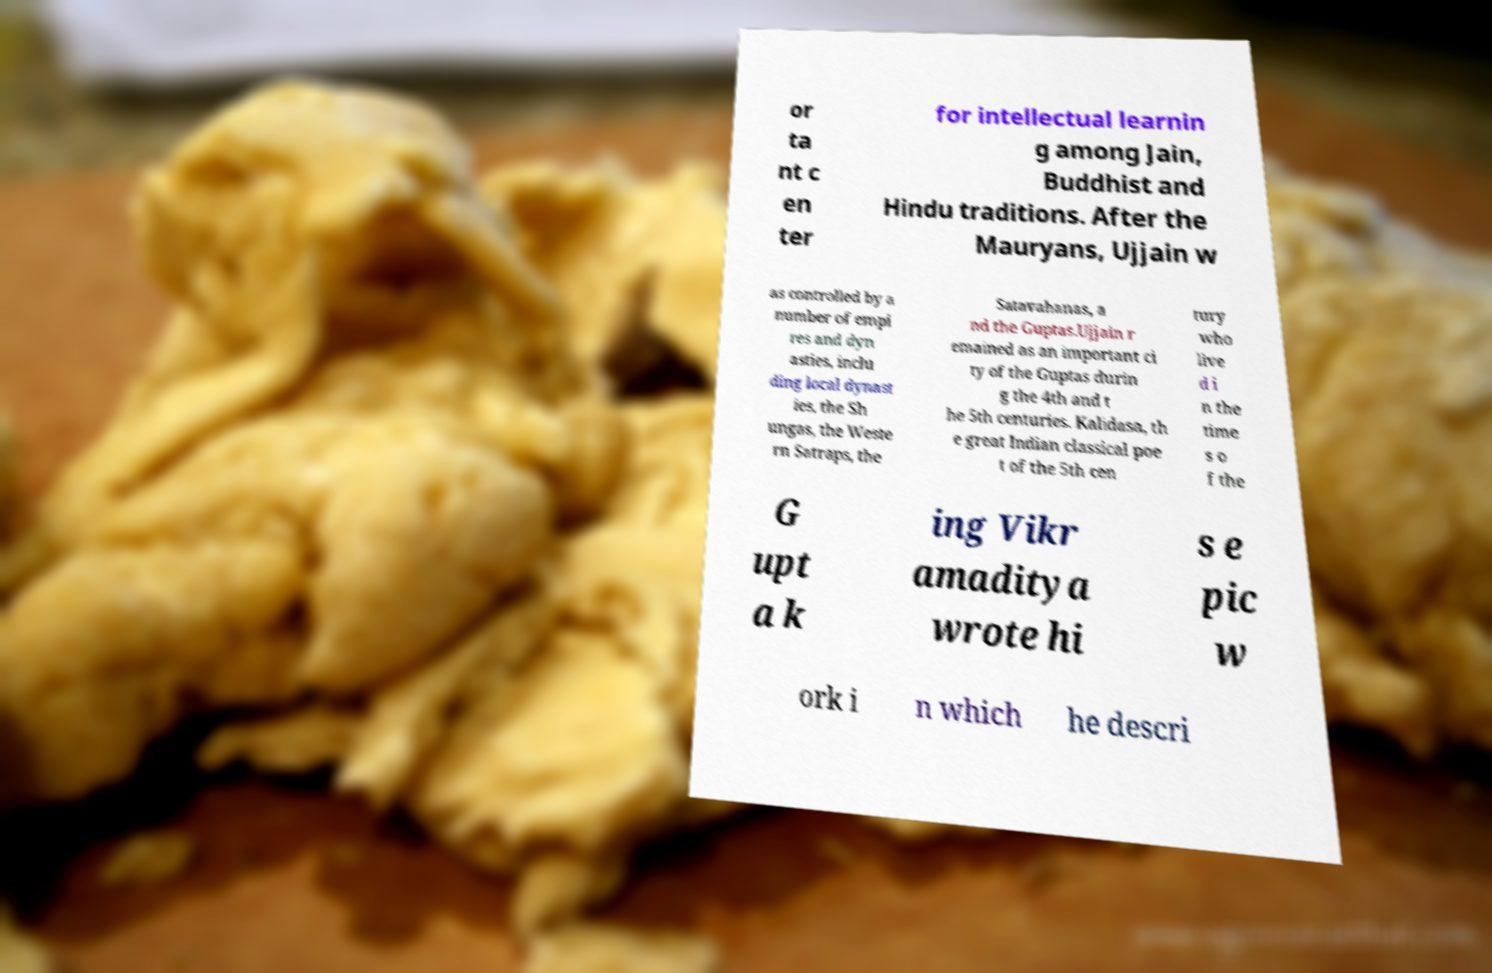For documentation purposes, I need the text within this image transcribed. Could you provide that? or ta nt c en ter for intellectual learnin g among Jain, Buddhist and Hindu traditions. After the Mauryans, Ujjain w as controlled by a number of empi res and dyn asties, inclu ding local dynast ies, the Sh ungas, the Weste rn Satraps, the Satavahanas, a nd the Guptas.Ujjain r emained as an important ci ty of the Guptas durin g the 4th and t he 5th centuries. Kalidasa, th e great Indian classical poe t of the 5th cen tury who live d i n the time s o f the G upt a k ing Vikr amaditya wrote hi s e pic w ork i n which he descri 